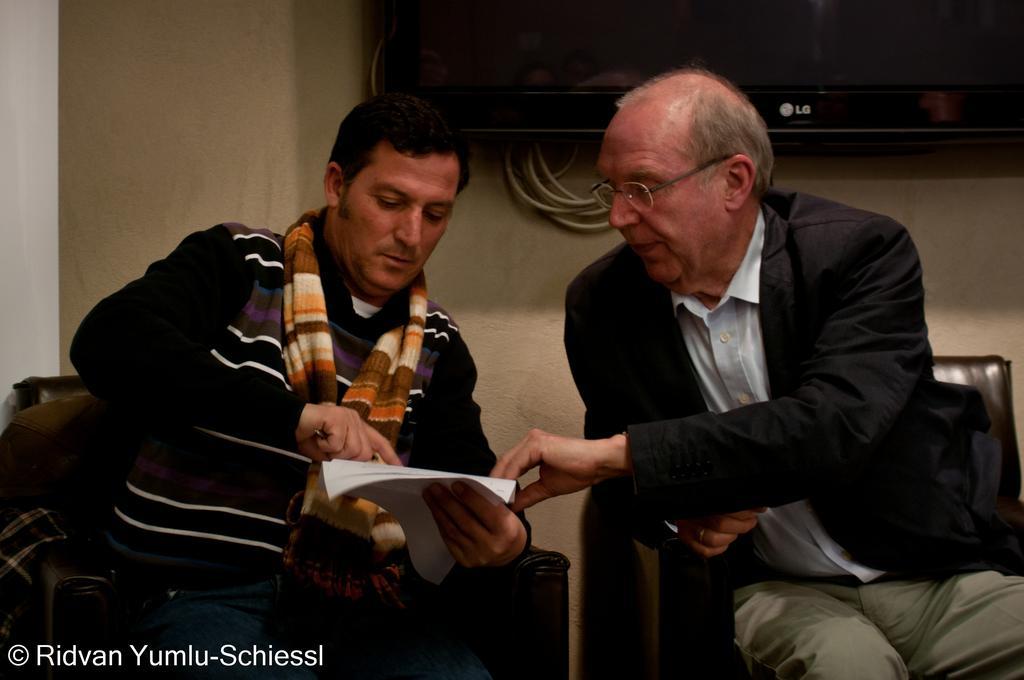In one or two sentences, can you explain what this image depicts? Here we can see two men sitting on the chairs and the person on the left is holding papers and an object in his hands. In the background there is a TV on the wall. 